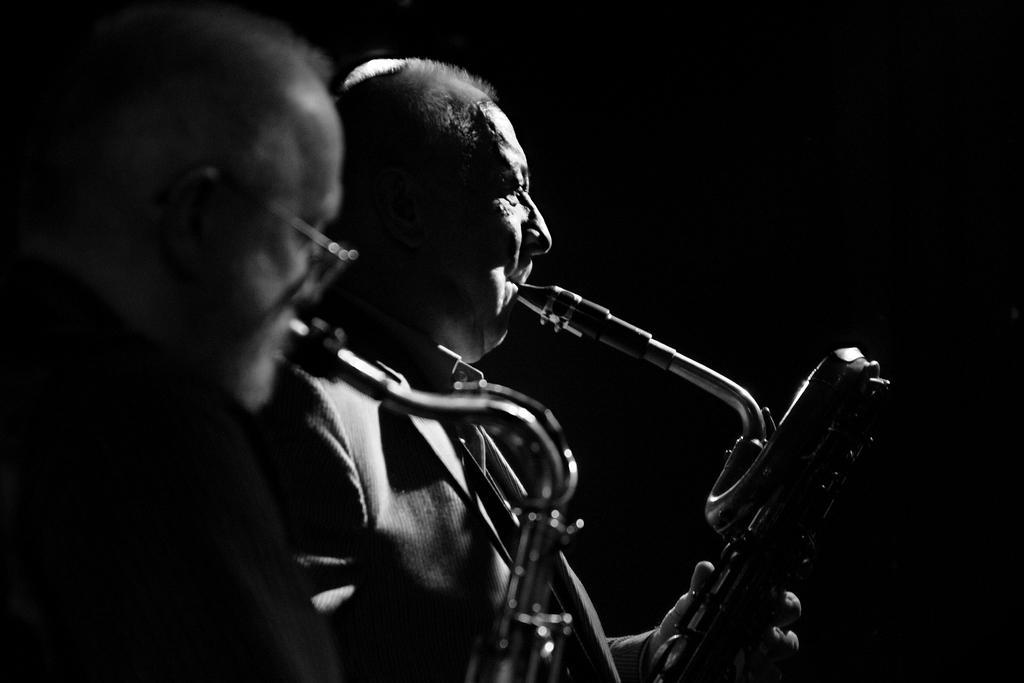How would you summarize this image in a sentence or two? This is a black and white image. On the left side of the image we can see two men are standing and playing the trumpets. In the background, the image is dark. 